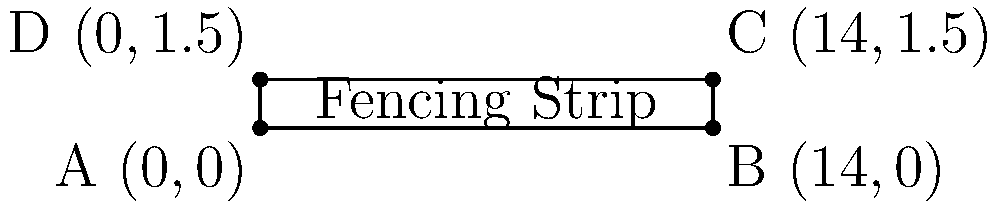A rectangular fencing strip is represented on a coordinate plane. The corners of the strip are located at the following points: A(0,0), B(14,0), C(14,1.5), and D(0,1.5). Calculate the perimeter of the fencing strip in meters. To find the perimeter of the rectangular fencing strip, we need to calculate the lengths of all four sides and add them together. Here's how we can do it step by step:

1. Calculate the length (l) of the strip:
   Length = distance between A and B (or D and C)
   $l = 14 - 0 = 14$ meters

2. Calculate the width (w) of the strip:
   Width = distance between A and D (or B and C)
   $w = 1.5 - 0 = 1.5$ meters

3. The perimeter of a rectangle is given by the formula:
   $P = 2l + 2w$

4. Substitute the values:
   $P = 2(14) + 2(1.5)$
   $P = 28 + 3$
   $P = 31$ meters

Therefore, the perimeter of the fencing strip is 31 meters.
Answer: 31 meters 